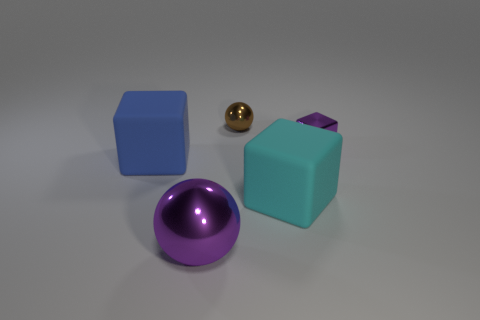Is the color of the shiny cube the same as the object behind the purple block? The shiny object is not a cube, but a sphere, and its color is gold. This is distinct from the object behind the purple block, which appears to be another cube with a similar turquoise shade to the one in the foreground but has a slightly different hue. 